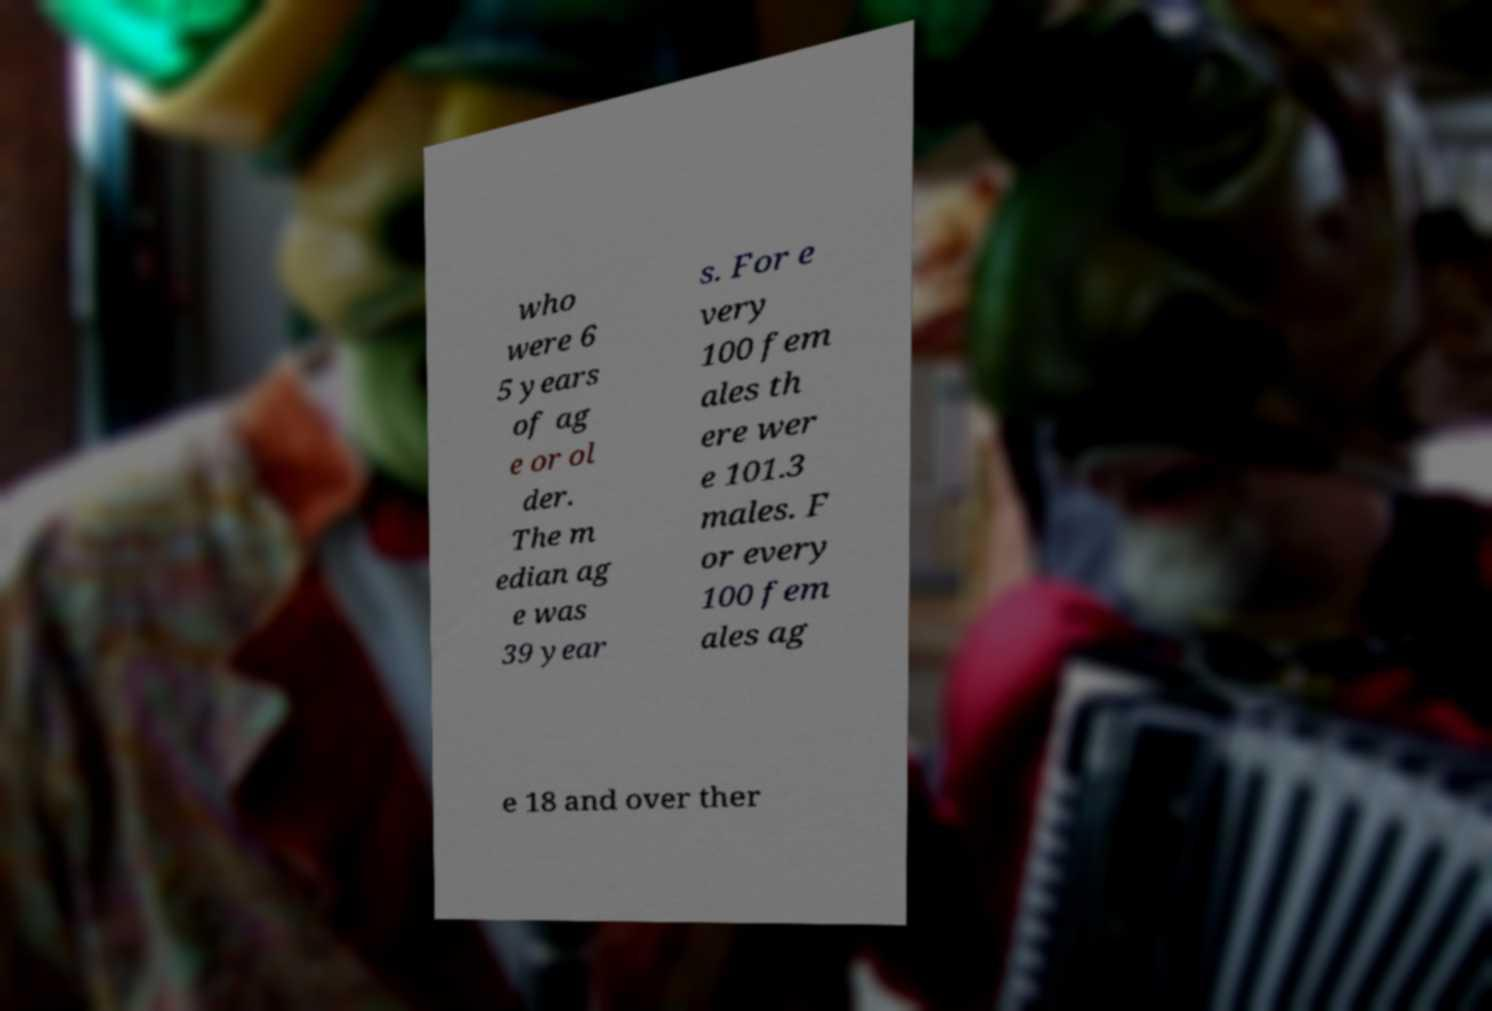Can you accurately transcribe the text from the provided image for me? who were 6 5 years of ag e or ol der. The m edian ag e was 39 year s. For e very 100 fem ales th ere wer e 101.3 males. F or every 100 fem ales ag e 18 and over ther 